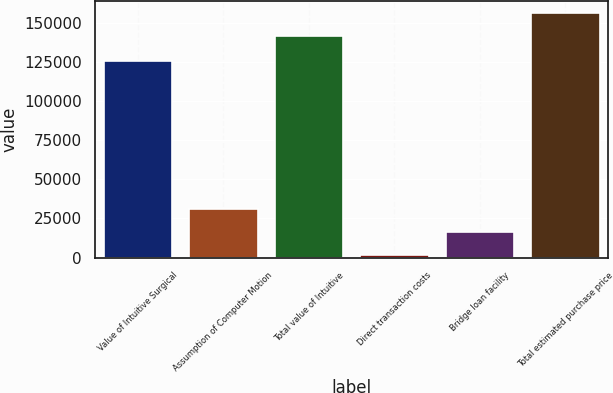<chart> <loc_0><loc_0><loc_500><loc_500><bar_chart><fcel>Value of Intuitive Surgical<fcel>Assumption of Computer Motion<fcel>Total value of Intuitive<fcel>Direct transaction costs<fcel>Bridge loan facility<fcel>Total estimated purchase price<nl><fcel>125734<fcel>31121.8<fcel>141437<fcel>1774<fcel>16447.9<fcel>156111<nl></chart> 